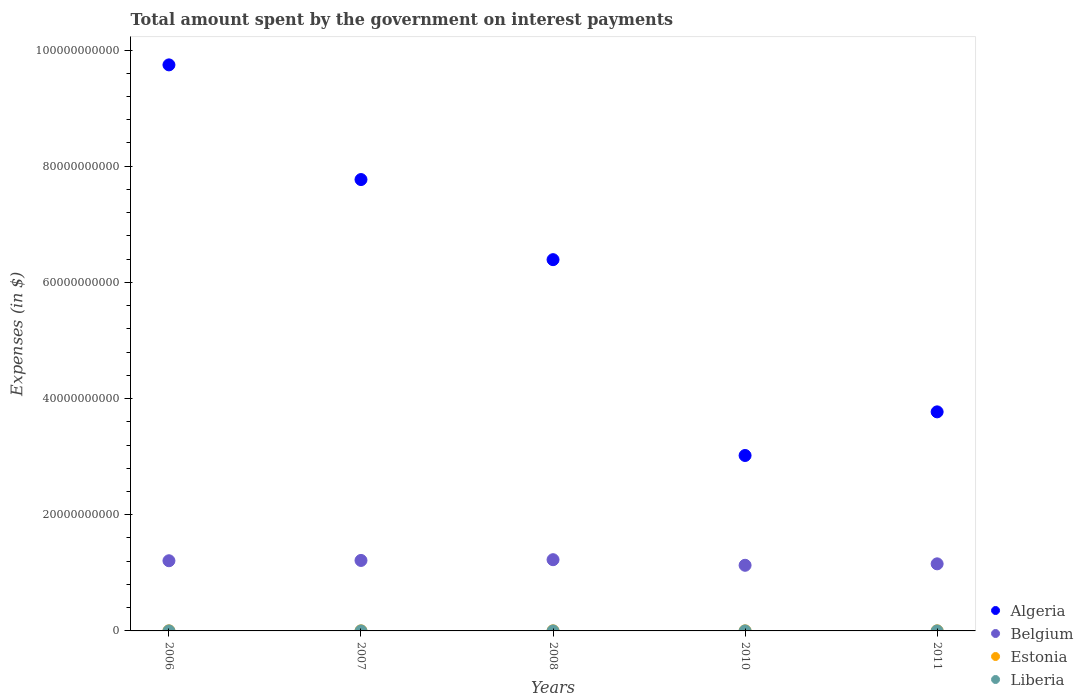How many different coloured dotlines are there?
Your answer should be very brief. 4. What is the amount spent on interest payments by the government in Algeria in 2007?
Your response must be concise. 7.77e+1. Across all years, what is the maximum amount spent on interest payments by the government in Algeria?
Your answer should be very brief. 9.74e+1. Across all years, what is the minimum amount spent on interest payments by the government in Liberia?
Keep it short and to the point. 2.07e+04. What is the total amount spent on interest payments by the government in Liberia in the graph?
Your answer should be very brief. 5.45e+05. What is the difference between the amount spent on interest payments by the government in Algeria in 2006 and the amount spent on interest payments by the government in Belgium in 2007?
Ensure brevity in your answer.  8.53e+1. What is the average amount spent on interest payments by the government in Liberia per year?
Your response must be concise. 1.09e+05. In the year 2008, what is the difference between the amount spent on interest payments by the government in Liberia and amount spent on interest payments by the government in Estonia?
Ensure brevity in your answer.  -1.31e+07. In how many years, is the amount spent on interest payments by the government in Estonia greater than 24000000000 $?
Ensure brevity in your answer.  0. What is the ratio of the amount spent on interest payments by the government in Algeria in 2006 to that in 2011?
Make the answer very short. 2.58. Is the difference between the amount spent on interest payments by the government in Liberia in 2007 and 2011 greater than the difference between the amount spent on interest payments by the government in Estonia in 2007 and 2011?
Provide a short and direct response. No. What is the difference between the highest and the second highest amount spent on interest payments by the government in Estonia?
Make the answer very short. 0. What is the difference between the highest and the lowest amount spent on interest payments by the government in Algeria?
Your answer should be very brief. 6.72e+1. Is the sum of the amount spent on interest payments by the government in Algeria in 2008 and 2010 greater than the maximum amount spent on interest payments by the government in Estonia across all years?
Keep it short and to the point. Yes. Does the amount spent on interest payments by the government in Liberia monotonically increase over the years?
Give a very brief answer. Yes. Is the amount spent on interest payments by the government in Belgium strictly greater than the amount spent on interest payments by the government in Estonia over the years?
Your answer should be very brief. Yes. How many dotlines are there?
Your response must be concise. 4. Does the graph contain any zero values?
Your answer should be very brief. No. Where does the legend appear in the graph?
Your answer should be compact. Bottom right. How are the legend labels stacked?
Ensure brevity in your answer.  Vertical. What is the title of the graph?
Your answer should be compact. Total amount spent by the government on interest payments. Does "Europe(all income levels)" appear as one of the legend labels in the graph?
Provide a succinct answer. No. What is the label or title of the X-axis?
Provide a short and direct response. Years. What is the label or title of the Y-axis?
Ensure brevity in your answer.  Expenses (in $). What is the Expenses (in $) in Algeria in 2006?
Make the answer very short. 9.74e+1. What is the Expenses (in $) of Belgium in 2006?
Keep it short and to the point. 1.21e+1. What is the Expenses (in $) in Estonia in 2006?
Ensure brevity in your answer.  1.32e+07. What is the Expenses (in $) in Liberia in 2006?
Keep it short and to the point. 2.07e+04. What is the Expenses (in $) in Algeria in 2007?
Keep it short and to the point. 7.77e+1. What is the Expenses (in $) in Belgium in 2007?
Offer a very short reply. 1.21e+1. What is the Expenses (in $) of Estonia in 2007?
Provide a short and direct response. 1.19e+07. What is the Expenses (in $) of Liberia in 2007?
Offer a very short reply. 2.20e+04. What is the Expenses (in $) of Algeria in 2008?
Make the answer very short. 6.39e+1. What is the Expenses (in $) in Belgium in 2008?
Provide a short and direct response. 1.23e+1. What is the Expenses (in $) in Estonia in 2008?
Keep it short and to the point. 1.32e+07. What is the Expenses (in $) in Liberia in 2008?
Keep it short and to the point. 7.01e+04. What is the Expenses (in $) of Algeria in 2010?
Ensure brevity in your answer.  3.02e+1. What is the Expenses (in $) in Belgium in 2010?
Provide a succinct answer. 1.13e+1. What is the Expenses (in $) in Estonia in 2010?
Provide a succinct answer. 8.20e+06. What is the Expenses (in $) in Liberia in 2010?
Make the answer very short. 1.88e+05. What is the Expenses (in $) of Algeria in 2011?
Offer a terse response. 3.77e+1. What is the Expenses (in $) of Belgium in 2011?
Your answer should be compact. 1.15e+1. What is the Expenses (in $) of Estonia in 2011?
Your answer should be compact. 1.07e+07. What is the Expenses (in $) of Liberia in 2011?
Keep it short and to the point. 2.44e+05. Across all years, what is the maximum Expenses (in $) of Algeria?
Your answer should be very brief. 9.74e+1. Across all years, what is the maximum Expenses (in $) of Belgium?
Provide a short and direct response. 1.23e+1. Across all years, what is the maximum Expenses (in $) in Estonia?
Provide a succinct answer. 1.32e+07. Across all years, what is the maximum Expenses (in $) in Liberia?
Provide a short and direct response. 2.44e+05. Across all years, what is the minimum Expenses (in $) of Algeria?
Provide a short and direct response. 3.02e+1. Across all years, what is the minimum Expenses (in $) of Belgium?
Keep it short and to the point. 1.13e+1. Across all years, what is the minimum Expenses (in $) in Estonia?
Make the answer very short. 8.20e+06. Across all years, what is the minimum Expenses (in $) in Liberia?
Your answer should be compact. 2.07e+04. What is the total Expenses (in $) of Algeria in the graph?
Offer a very short reply. 3.07e+11. What is the total Expenses (in $) of Belgium in the graph?
Your answer should be compact. 5.93e+1. What is the total Expenses (in $) in Estonia in the graph?
Provide a short and direct response. 5.72e+07. What is the total Expenses (in $) of Liberia in the graph?
Keep it short and to the point. 5.45e+05. What is the difference between the Expenses (in $) of Algeria in 2006 and that in 2007?
Your answer should be compact. 1.97e+1. What is the difference between the Expenses (in $) in Belgium in 2006 and that in 2007?
Keep it short and to the point. -5.26e+07. What is the difference between the Expenses (in $) in Estonia in 2006 and that in 2007?
Keep it short and to the point. 1.30e+06. What is the difference between the Expenses (in $) of Liberia in 2006 and that in 2007?
Ensure brevity in your answer.  -1373.52. What is the difference between the Expenses (in $) in Algeria in 2006 and that in 2008?
Keep it short and to the point. 3.35e+1. What is the difference between the Expenses (in $) in Belgium in 2006 and that in 2008?
Ensure brevity in your answer.  -1.81e+08. What is the difference between the Expenses (in $) of Liberia in 2006 and that in 2008?
Offer a terse response. -4.94e+04. What is the difference between the Expenses (in $) in Algeria in 2006 and that in 2010?
Your answer should be compact. 6.72e+1. What is the difference between the Expenses (in $) in Belgium in 2006 and that in 2010?
Keep it short and to the point. 7.81e+08. What is the difference between the Expenses (in $) in Estonia in 2006 and that in 2010?
Ensure brevity in your answer.  5.00e+06. What is the difference between the Expenses (in $) of Liberia in 2006 and that in 2010?
Your response must be concise. -1.68e+05. What is the difference between the Expenses (in $) of Algeria in 2006 and that in 2011?
Provide a short and direct response. 5.97e+1. What is the difference between the Expenses (in $) in Belgium in 2006 and that in 2011?
Make the answer very short. 5.33e+08. What is the difference between the Expenses (in $) in Estonia in 2006 and that in 2011?
Ensure brevity in your answer.  2.50e+06. What is the difference between the Expenses (in $) in Liberia in 2006 and that in 2011?
Keep it short and to the point. -2.24e+05. What is the difference between the Expenses (in $) in Algeria in 2007 and that in 2008?
Offer a very short reply. 1.38e+1. What is the difference between the Expenses (in $) in Belgium in 2007 and that in 2008?
Keep it short and to the point. -1.29e+08. What is the difference between the Expenses (in $) in Estonia in 2007 and that in 2008?
Make the answer very short. -1.30e+06. What is the difference between the Expenses (in $) of Liberia in 2007 and that in 2008?
Your response must be concise. -4.80e+04. What is the difference between the Expenses (in $) in Algeria in 2007 and that in 2010?
Your answer should be compact. 4.75e+1. What is the difference between the Expenses (in $) in Belgium in 2007 and that in 2010?
Your response must be concise. 8.33e+08. What is the difference between the Expenses (in $) of Estonia in 2007 and that in 2010?
Your answer should be compact. 3.70e+06. What is the difference between the Expenses (in $) of Liberia in 2007 and that in 2010?
Your response must be concise. -1.66e+05. What is the difference between the Expenses (in $) of Algeria in 2007 and that in 2011?
Keep it short and to the point. 4.00e+1. What is the difference between the Expenses (in $) in Belgium in 2007 and that in 2011?
Give a very brief answer. 5.85e+08. What is the difference between the Expenses (in $) in Estonia in 2007 and that in 2011?
Provide a succinct answer. 1.20e+06. What is the difference between the Expenses (in $) of Liberia in 2007 and that in 2011?
Your response must be concise. -2.22e+05. What is the difference between the Expenses (in $) in Algeria in 2008 and that in 2010?
Provide a short and direct response. 3.37e+1. What is the difference between the Expenses (in $) of Belgium in 2008 and that in 2010?
Make the answer very short. 9.62e+08. What is the difference between the Expenses (in $) in Estonia in 2008 and that in 2010?
Provide a succinct answer. 5.00e+06. What is the difference between the Expenses (in $) in Liberia in 2008 and that in 2010?
Your response must be concise. -1.18e+05. What is the difference between the Expenses (in $) of Algeria in 2008 and that in 2011?
Provide a short and direct response. 2.62e+1. What is the difference between the Expenses (in $) of Belgium in 2008 and that in 2011?
Your response must be concise. 7.14e+08. What is the difference between the Expenses (in $) of Estonia in 2008 and that in 2011?
Keep it short and to the point. 2.50e+06. What is the difference between the Expenses (in $) in Liberia in 2008 and that in 2011?
Make the answer very short. -1.74e+05. What is the difference between the Expenses (in $) of Algeria in 2010 and that in 2011?
Provide a succinct answer. -7.51e+09. What is the difference between the Expenses (in $) in Belgium in 2010 and that in 2011?
Your answer should be very brief. -2.48e+08. What is the difference between the Expenses (in $) of Estonia in 2010 and that in 2011?
Provide a short and direct response. -2.50e+06. What is the difference between the Expenses (in $) of Liberia in 2010 and that in 2011?
Make the answer very short. -5.61e+04. What is the difference between the Expenses (in $) of Algeria in 2006 and the Expenses (in $) of Belgium in 2007?
Provide a succinct answer. 8.53e+1. What is the difference between the Expenses (in $) in Algeria in 2006 and the Expenses (in $) in Estonia in 2007?
Ensure brevity in your answer.  9.74e+1. What is the difference between the Expenses (in $) in Algeria in 2006 and the Expenses (in $) in Liberia in 2007?
Make the answer very short. 9.74e+1. What is the difference between the Expenses (in $) of Belgium in 2006 and the Expenses (in $) of Estonia in 2007?
Keep it short and to the point. 1.21e+1. What is the difference between the Expenses (in $) in Belgium in 2006 and the Expenses (in $) in Liberia in 2007?
Make the answer very short. 1.21e+1. What is the difference between the Expenses (in $) of Estonia in 2006 and the Expenses (in $) of Liberia in 2007?
Make the answer very short. 1.32e+07. What is the difference between the Expenses (in $) of Algeria in 2006 and the Expenses (in $) of Belgium in 2008?
Give a very brief answer. 8.52e+1. What is the difference between the Expenses (in $) in Algeria in 2006 and the Expenses (in $) in Estonia in 2008?
Provide a succinct answer. 9.74e+1. What is the difference between the Expenses (in $) in Algeria in 2006 and the Expenses (in $) in Liberia in 2008?
Offer a terse response. 9.74e+1. What is the difference between the Expenses (in $) in Belgium in 2006 and the Expenses (in $) in Estonia in 2008?
Your answer should be compact. 1.21e+1. What is the difference between the Expenses (in $) of Belgium in 2006 and the Expenses (in $) of Liberia in 2008?
Offer a terse response. 1.21e+1. What is the difference between the Expenses (in $) of Estonia in 2006 and the Expenses (in $) of Liberia in 2008?
Your response must be concise. 1.31e+07. What is the difference between the Expenses (in $) in Algeria in 2006 and the Expenses (in $) in Belgium in 2010?
Keep it short and to the point. 8.61e+1. What is the difference between the Expenses (in $) in Algeria in 2006 and the Expenses (in $) in Estonia in 2010?
Make the answer very short. 9.74e+1. What is the difference between the Expenses (in $) in Algeria in 2006 and the Expenses (in $) in Liberia in 2010?
Give a very brief answer. 9.74e+1. What is the difference between the Expenses (in $) in Belgium in 2006 and the Expenses (in $) in Estonia in 2010?
Offer a very short reply. 1.21e+1. What is the difference between the Expenses (in $) of Belgium in 2006 and the Expenses (in $) of Liberia in 2010?
Provide a succinct answer. 1.21e+1. What is the difference between the Expenses (in $) in Estonia in 2006 and the Expenses (in $) in Liberia in 2010?
Ensure brevity in your answer.  1.30e+07. What is the difference between the Expenses (in $) of Algeria in 2006 and the Expenses (in $) of Belgium in 2011?
Make the answer very short. 8.59e+1. What is the difference between the Expenses (in $) of Algeria in 2006 and the Expenses (in $) of Estonia in 2011?
Your answer should be very brief. 9.74e+1. What is the difference between the Expenses (in $) of Algeria in 2006 and the Expenses (in $) of Liberia in 2011?
Your response must be concise. 9.74e+1. What is the difference between the Expenses (in $) in Belgium in 2006 and the Expenses (in $) in Estonia in 2011?
Offer a very short reply. 1.21e+1. What is the difference between the Expenses (in $) in Belgium in 2006 and the Expenses (in $) in Liberia in 2011?
Your answer should be compact. 1.21e+1. What is the difference between the Expenses (in $) of Estonia in 2006 and the Expenses (in $) of Liberia in 2011?
Provide a succinct answer. 1.30e+07. What is the difference between the Expenses (in $) in Algeria in 2007 and the Expenses (in $) in Belgium in 2008?
Provide a succinct answer. 6.54e+1. What is the difference between the Expenses (in $) of Algeria in 2007 and the Expenses (in $) of Estonia in 2008?
Your response must be concise. 7.77e+1. What is the difference between the Expenses (in $) of Algeria in 2007 and the Expenses (in $) of Liberia in 2008?
Ensure brevity in your answer.  7.77e+1. What is the difference between the Expenses (in $) of Belgium in 2007 and the Expenses (in $) of Estonia in 2008?
Offer a terse response. 1.21e+1. What is the difference between the Expenses (in $) in Belgium in 2007 and the Expenses (in $) in Liberia in 2008?
Keep it short and to the point. 1.21e+1. What is the difference between the Expenses (in $) of Estonia in 2007 and the Expenses (in $) of Liberia in 2008?
Your answer should be very brief. 1.18e+07. What is the difference between the Expenses (in $) of Algeria in 2007 and the Expenses (in $) of Belgium in 2010?
Offer a very short reply. 6.64e+1. What is the difference between the Expenses (in $) of Algeria in 2007 and the Expenses (in $) of Estonia in 2010?
Make the answer very short. 7.77e+1. What is the difference between the Expenses (in $) of Algeria in 2007 and the Expenses (in $) of Liberia in 2010?
Make the answer very short. 7.77e+1. What is the difference between the Expenses (in $) of Belgium in 2007 and the Expenses (in $) of Estonia in 2010?
Ensure brevity in your answer.  1.21e+1. What is the difference between the Expenses (in $) of Belgium in 2007 and the Expenses (in $) of Liberia in 2010?
Provide a short and direct response. 1.21e+1. What is the difference between the Expenses (in $) in Estonia in 2007 and the Expenses (in $) in Liberia in 2010?
Your answer should be very brief. 1.17e+07. What is the difference between the Expenses (in $) in Algeria in 2007 and the Expenses (in $) in Belgium in 2011?
Keep it short and to the point. 6.62e+1. What is the difference between the Expenses (in $) in Algeria in 2007 and the Expenses (in $) in Estonia in 2011?
Provide a succinct answer. 7.77e+1. What is the difference between the Expenses (in $) in Algeria in 2007 and the Expenses (in $) in Liberia in 2011?
Your answer should be very brief. 7.77e+1. What is the difference between the Expenses (in $) of Belgium in 2007 and the Expenses (in $) of Estonia in 2011?
Ensure brevity in your answer.  1.21e+1. What is the difference between the Expenses (in $) in Belgium in 2007 and the Expenses (in $) in Liberia in 2011?
Your answer should be compact. 1.21e+1. What is the difference between the Expenses (in $) in Estonia in 2007 and the Expenses (in $) in Liberia in 2011?
Provide a succinct answer. 1.17e+07. What is the difference between the Expenses (in $) in Algeria in 2008 and the Expenses (in $) in Belgium in 2010?
Make the answer very short. 5.26e+1. What is the difference between the Expenses (in $) of Algeria in 2008 and the Expenses (in $) of Estonia in 2010?
Keep it short and to the point. 6.39e+1. What is the difference between the Expenses (in $) in Algeria in 2008 and the Expenses (in $) in Liberia in 2010?
Provide a succinct answer. 6.39e+1. What is the difference between the Expenses (in $) of Belgium in 2008 and the Expenses (in $) of Estonia in 2010?
Provide a succinct answer. 1.23e+1. What is the difference between the Expenses (in $) of Belgium in 2008 and the Expenses (in $) of Liberia in 2010?
Give a very brief answer. 1.23e+1. What is the difference between the Expenses (in $) of Estonia in 2008 and the Expenses (in $) of Liberia in 2010?
Give a very brief answer. 1.30e+07. What is the difference between the Expenses (in $) of Algeria in 2008 and the Expenses (in $) of Belgium in 2011?
Offer a very short reply. 5.24e+1. What is the difference between the Expenses (in $) of Algeria in 2008 and the Expenses (in $) of Estonia in 2011?
Keep it short and to the point. 6.39e+1. What is the difference between the Expenses (in $) of Algeria in 2008 and the Expenses (in $) of Liberia in 2011?
Your answer should be compact. 6.39e+1. What is the difference between the Expenses (in $) of Belgium in 2008 and the Expenses (in $) of Estonia in 2011?
Ensure brevity in your answer.  1.23e+1. What is the difference between the Expenses (in $) of Belgium in 2008 and the Expenses (in $) of Liberia in 2011?
Provide a short and direct response. 1.23e+1. What is the difference between the Expenses (in $) in Estonia in 2008 and the Expenses (in $) in Liberia in 2011?
Provide a succinct answer. 1.30e+07. What is the difference between the Expenses (in $) in Algeria in 2010 and the Expenses (in $) in Belgium in 2011?
Give a very brief answer. 1.87e+1. What is the difference between the Expenses (in $) of Algeria in 2010 and the Expenses (in $) of Estonia in 2011?
Give a very brief answer. 3.02e+1. What is the difference between the Expenses (in $) in Algeria in 2010 and the Expenses (in $) in Liberia in 2011?
Offer a terse response. 3.02e+1. What is the difference between the Expenses (in $) in Belgium in 2010 and the Expenses (in $) in Estonia in 2011?
Provide a short and direct response. 1.13e+1. What is the difference between the Expenses (in $) of Belgium in 2010 and the Expenses (in $) of Liberia in 2011?
Provide a short and direct response. 1.13e+1. What is the difference between the Expenses (in $) in Estonia in 2010 and the Expenses (in $) in Liberia in 2011?
Make the answer very short. 7.96e+06. What is the average Expenses (in $) in Algeria per year?
Your answer should be compact. 6.14e+1. What is the average Expenses (in $) of Belgium per year?
Provide a succinct answer. 1.19e+1. What is the average Expenses (in $) of Estonia per year?
Your response must be concise. 1.14e+07. What is the average Expenses (in $) in Liberia per year?
Offer a terse response. 1.09e+05. In the year 2006, what is the difference between the Expenses (in $) of Algeria and Expenses (in $) of Belgium?
Your response must be concise. 8.54e+1. In the year 2006, what is the difference between the Expenses (in $) in Algeria and Expenses (in $) in Estonia?
Make the answer very short. 9.74e+1. In the year 2006, what is the difference between the Expenses (in $) in Algeria and Expenses (in $) in Liberia?
Your response must be concise. 9.74e+1. In the year 2006, what is the difference between the Expenses (in $) of Belgium and Expenses (in $) of Estonia?
Give a very brief answer. 1.21e+1. In the year 2006, what is the difference between the Expenses (in $) in Belgium and Expenses (in $) in Liberia?
Your response must be concise. 1.21e+1. In the year 2006, what is the difference between the Expenses (in $) of Estonia and Expenses (in $) of Liberia?
Offer a very short reply. 1.32e+07. In the year 2007, what is the difference between the Expenses (in $) of Algeria and Expenses (in $) of Belgium?
Provide a short and direct response. 6.56e+1. In the year 2007, what is the difference between the Expenses (in $) in Algeria and Expenses (in $) in Estonia?
Give a very brief answer. 7.77e+1. In the year 2007, what is the difference between the Expenses (in $) in Algeria and Expenses (in $) in Liberia?
Your response must be concise. 7.77e+1. In the year 2007, what is the difference between the Expenses (in $) of Belgium and Expenses (in $) of Estonia?
Ensure brevity in your answer.  1.21e+1. In the year 2007, what is the difference between the Expenses (in $) of Belgium and Expenses (in $) of Liberia?
Your response must be concise. 1.21e+1. In the year 2007, what is the difference between the Expenses (in $) of Estonia and Expenses (in $) of Liberia?
Offer a terse response. 1.19e+07. In the year 2008, what is the difference between the Expenses (in $) in Algeria and Expenses (in $) in Belgium?
Provide a short and direct response. 5.16e+1. In the year 2008, what is the difference between the Expenses (in $) in Algeria and Expenses (in $) in Estonia?
Make the answer very short. 6.39e+1. In the year 2008, what is the difference between the Expenses (in $) in Algeria and Expenses (in $) in Liberia?
Provide a succinct answer. 6.39e+1. In the year 2008, what is the difference between the Expenses (in $) of Belgium and Expenses (in $) of Estonia?
Offer a very short reply. 1.22e+1. In the year 2008, what is the difference between the Expenses (in $) of Belgium and Expenses (in $) of Liberia?
Give a very brief answer. 1.23e+1. In the year 2008, what is the difference between the Expenses (in $) in Estonia and Expenses (in $) in Liberia?
Provide a short and direct response. 1.31e+07. In the year 2010, what is the difference between the Expenses (in $) of Algeria and Expenses (in $) of Belgium?
Ensure brevity in your answer.  1.89e+1. In the year 2010, what is the difference between the Expenses (in $) of Algeria and Expenses (in $) of Estonia?
Offer a very short reply. 3.02e+1. In the year 2010, what is the difference between the Expenses (in $) of Algeria and Expenses (in $) of Liberia?
Your answer should be very brief. 3.02e+1. In the year 2010, what is the difference between the Expenses (in $) in Belgium and Expenses (in $) in Estonia?
Make the answer very short. 1.13e+1. In the year 2010, what is the difference between the Expenses (in $) in Belgium and Expenses (in $) in Liberia?
Provide a short and direct response. 1.13e+1. In the year 2010, what is the difference between the Expenses (in $) in Estonia and Expenses (in $) in Liberia?
Keep it short and to the point. 8.01e+06. In the year 2011, what is the difference between the Expenses (in $) in Algeria and Expenses (in $) in Belgium?
Your answer should be very brief. 2.62e+1. In the year 2011, what is the difference between the Expenses (in $) in Algeria and Expenses (in $) in Estonia?
Give a very brief answer. 3.77e+1. In the year 2011, what is the difference between the Expenses (in $) of Algeria and Expenses (in $) of Liberia?
Provide a succinct answer. 3.77e+1. In the year 2011, what is the difference between the Expenses (in $) in Belgium and Expenses (in $) in Estonia?
Provide a succinct answer. 1.15e+1. In the year 2011, what is the difference between the Expenses (in $) in Belgium and Expenses (in $) in Liberia?
Make the answer very short. 1.15e+1. In the year 2011, what is the difference between the Expenses (in $) in Estonia and Expenses (in $) in Liberia?
Keep it short and to the point. 1.05e+07. What is the ratio of the Expenses (in $) in Algeria in 2006 to that in 2007?
Offer a very short reply. 1.25. What is the ratio of the Expenses (in $) of Estonia in 2006 to that in 2007?
Provide a short and direct response. 1.11. What is the ratio of the Expenses (in $) in Liberia in 2006 to that in 2007?
Provide a succinct answer. 0.94. What is the ratio of the Expenses (in $) in Algeria in 2006 to that in 2008?
Make the answer very short. 1.52. What is the ratio of the Expenses (in $) of Belgium in 2006 to that in 2008?
Your response must be concise. 0.99. What is the ratio of the Expenses (in $) of Estonia in 2006 to that in 2008?
Give a very brief answer. 1. What is the ratio of the Expenses (in $) in Liberia in 2006 to that in 2008?
Provide a succinct answer. 0.29. What is the ratio of the Expenses (in $) of Algeria in 2006 to that in 2010?
Your response must be concise. 3.23. What is the ratio of the Expenses (in $) of Belgium in 2006 to that in 2010?
Ensure brevity in your answer.  1.07. What is the ratio of the Expenses (in $) of Estonia in 2006 to that in 2010?
Make the answer very short. 1.61. What is the ratio of the Expenses (in $) of Liberia in 2006 to that in 2010?
Ensure brevity in your answer.  0.11. What is the ratio of the Expenses (in $) in Algeria in 2006 to that in 2011?
Your response must be concise. 2.58. What is the ratio of the Expenses (in $) in Belgium in 2006 to that in 2011?
Ensure brevity in your answer.  1.05. What is the ratio of the Expenses (in $) of Estonia in 2006 to that in 2011?
Ensure brevity in your answer.  1.23. What is the ratio of the Expenses (in $) of Liberia in 2006 to that in 2011?
Make the answer very short. 0.08. What is the ratio of the Expenses (in $) of Algeria in 2007 to that in 2008?
Ensure brevity in your answer.  1.22. What is the ratio of the Expenses (in $) in Belgium in 2007 to that in 2008?
Offer a very short reply. 0.99. What is the ratio of the Expenses (in $) of Estonia in 2007 to that in 2008?
Offer a very short reply. 0.9. What is the ratio of the Expenses (in $) of Liberia in 2007 to that in 2008?
Your answer should be very brief. 0.31. What is the ratio of the Expenses (in $) in Algeria in 2007 to that in 2010?
Give a very brief answer. 2.57. What is the ratio of the Expenses (in $) of Belgium in 2007 to that in 2010?
Offer a very short reply. 1.07. What is the ratio of the Expenses (in $) in Estonia in 2007 to that in 2010?
Your answer should be compact. 1.45. What is the ratio of the Expenses (in $) of Liberia in 2007 to that in 2010?
Ensure brevity in your answer.  0.12. What is the ratio of the Expenses (in $) in Algeria in 2007 to that in 2011?
Ensure brevity in your answer.  2.06. What is the ratio of the Expenses (in $) of Belgium in 2007 to that in 2011?
Provide a succinct answer. 1.05. What is the ratio of the Expenses (in $) of Estonia in 2007 to that in 2011?
Keep it short and to the point. 1.11. What is the ratio of the Expenses (in $) of Liberia in 2007 to that in 2011?
Give a very brief answer. 0.09. What is the ratio of the Expenses (in $) in Algeria in 2008 to that in 2010?
Your response must be concise. 2.12. What is the ratio of the Expenses (in $) in Belgium in 2008 to that in 2010?
Provide a succinct answer. 1.09. What is the ratio of the Expenses (in $) in Estonia in 2008 to that in 2010?
Your answer should be compact. 1.61. What is the ratio of the Expenses (in $) in Liberia in 2008 to that in 2010?
Offer a terse response. 0.37. What is the ratio of the Expenses (in $) in Algeria in 2008 to that in 2011?
Offer a terse response. 1.69. What is the ratio of the Expenses (in $) of Belgium in 2008 to that in 2011?
Your response must be concise. 1.06. What is the ratio of the Expenses (in $) of Estonia in 2008 to that in 2011?
Offer a terse response. 1.23. What is the ratio of the Expenses (in $) of Liberia in 2008 to that in 2011?
Make the answer very short. 0.29. What is the ratio of the Expenses (in $) of Algeria in 2010 to that in 2011?
Offer a very short reply. 0.8. What is the ratio of the Expenses (in $) of Belgium in 2010 to that in 2011?
Offer a terse response. 0.98. What is the ratio of the Expenses (in $) in Estonia in 2010 to that in 2011?
Give a very brief answer. 0.77. What is the ratio of the Expenses (in $) in Liberia in 2010 to that in 2011?
Give a very brief answer. 0.77. What is the difference between the highest and the second highest Expenses (in $) of Algeria?
Provide a succinct answer. 1.97e+1. What is the difference between the highest and the second highest Expenses (in $) of Belgium?
Keep it short and to the point. 1.29e+08. What is the difference between the highest and the second highest Expenses (in $) in Estonia?
Make the answer very short. 0. What is the difference between the highest and the second highest Expenses (in $) in Liberia?
Offer a very short reply. 5.61e+04. What is the difference between the highest and the lowest Expenses (in $) in Algeria?
Your answer should be very brief. 6.72e+1. What is the difference between the highest and the lowest Expenses (in $) in Belgium?
Provide a short and direct response. 9.62e+08. What is the difference between the highest and the lowest Expenses (in $) of Estonia?
Give a very brief answer. 5.00e+06. What is the difference between the highest and the lowest Expenses (in $) in Liberia?
Keep it short and to the point. 2.24e+05. 